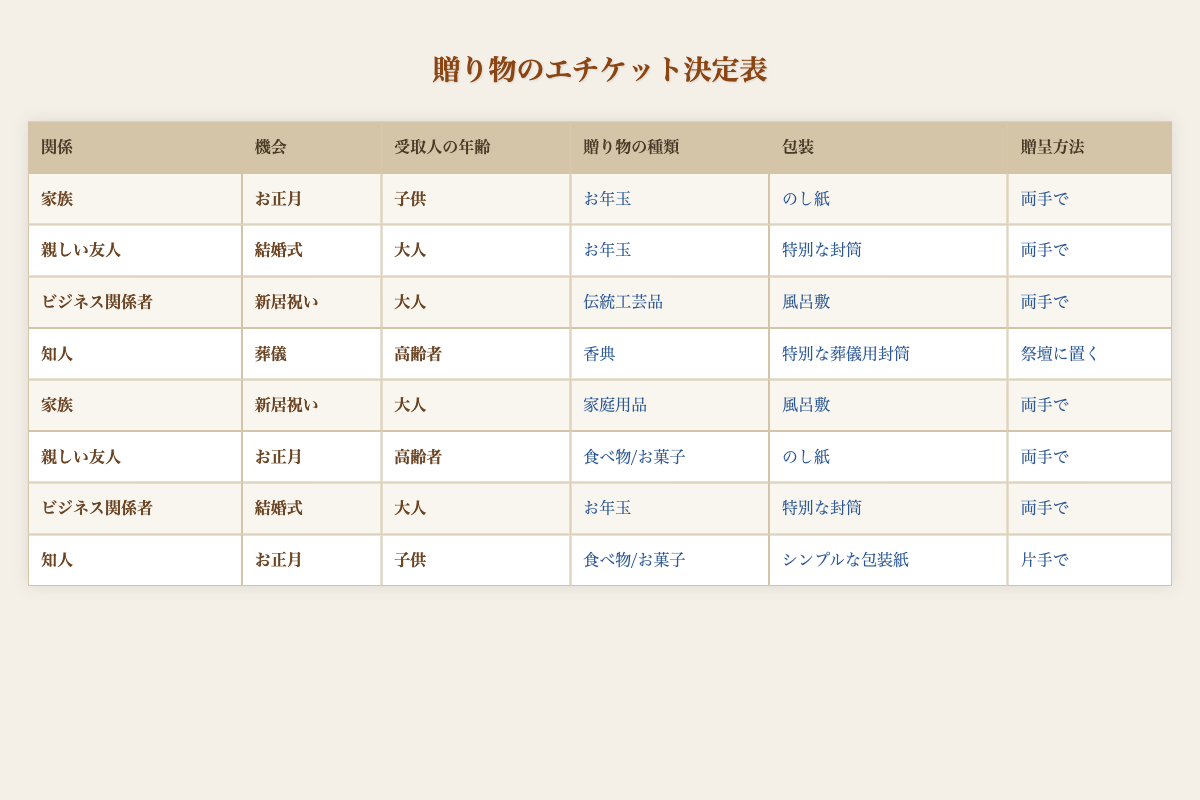What type of gift should I give to a child in the family during New Year? The table shows that for the relationship of family, occasion New Year, and recipient age child, the suggested gift type is cash (Otoshidama).
Answer: Cash (Otoshidama) For a business associate's wedding, how should the gift be presented? According to the table, when gifting to a business associate for a wedding, the presentation should be done with both hands.
Answer: Both hands Is it appropriate to give a household item to a close friend on a housewarming occasion? Looking at the table, there is no entry where a household item is given to a close friend during a housewarming occasion, so it is not appropriate.
Answer: No What wrapping should be used for a condolence gift given to an elderly acquaintance? The table specifies that for an acquaintance at a funeral for an elderly recipient, a special funeral envelope is to be used for wrapping the gift.
Answer: Special funeral envelope If I give food or sweets to a close friend on New Year, how should I present it? The table indicates that when gifting food or sweets to a close friend during New Year, the presentation should be done with both hands.
Answer: Both hands What is the gift type for an acquaintance’s child during New Year? From the table, it can be seen that for an acquaintance’s child on New Year, the suggested gift type is food/sweets.
Answer: Food/sweets Are there any cases where a traditional craft is gifted to an adult? The table shows that a traditional craft is given to a business associate for a housewarming occasion but does not imply it is given in any other scenario for adults.
Answer: Yes For a family member’s housewarming, what is the appropriate wrapping type? The table states that for a family member's housewarming occasion, the appropriate wrapping type is Furoshiki (cloth).
Answer: Furoshiki (cloth) What types of gifts are suggested for adults based on their relationships? By analyzing the table, adults receive cash (Otoshidama) and special envelopes for close friends and business associates’ weddings, and traditional crafts for business associates on housewarming occasions. The gifts range from cash, traditional crafts, and household items.
Answer: Cash, traditional crafts, household items 